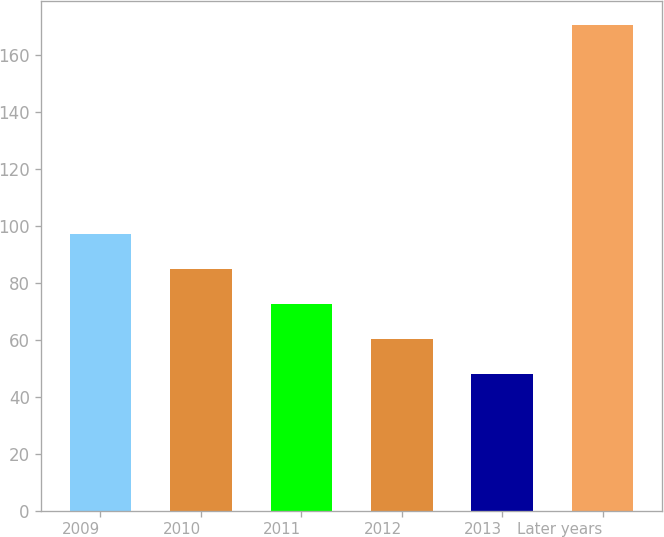<chart> <loc_0><loc_0><loc_500><loc_500><bar_chart><fcel>2009<fcel>2010<fcel>2011<fcel>2012<fcel>2013<fcel>Later years<nl><fcel>97.08<fcel>84.81<fcel>72.54<fcel>60.27<fcel>48<fcel>170.7<nl></chart> 